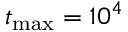<formula> <loc_0><loc_0><loc_500><loc_500>t _ { \max } = 1 0 ^ { 4 }</formula> 